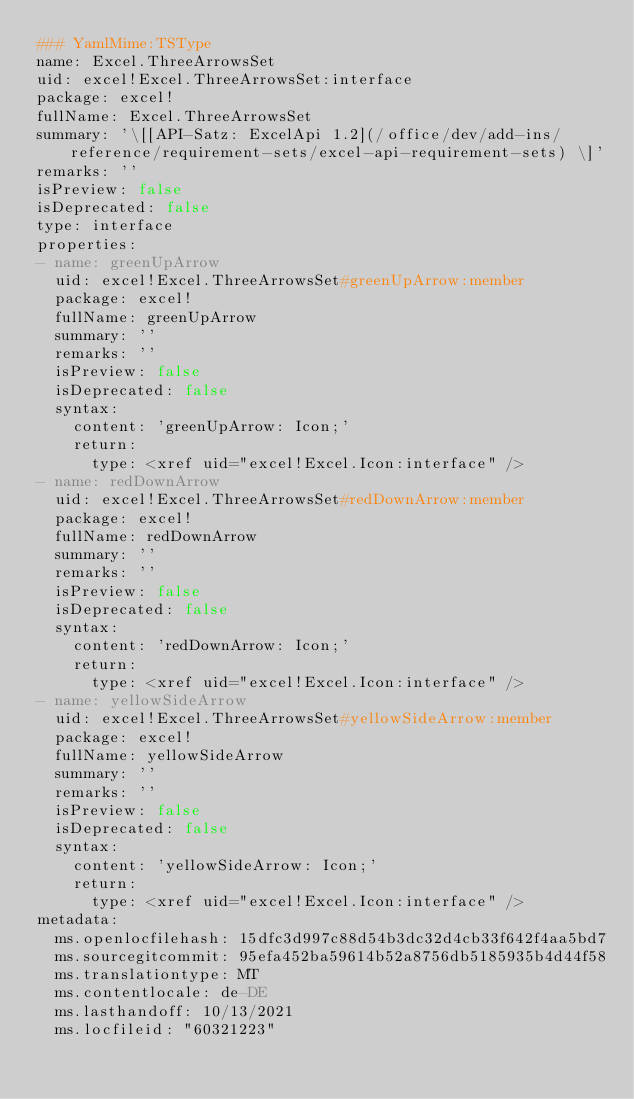<code> <loc_0><loc_0><loc_500><loc_500><_YAML_>### YamlMime:TSType
name: Excel.ThreeArrowsSet
uid: excel!Excel.ThreeArrowsSet:interface
package: excel!
fullName: Excel.ThreeArrowsSet
summary: '\[[API-Satz: ExcelApi 1.2](/office/dev/add-ins/reference/requirement-sets/excel-api-requirement-sets) \]'
remarks: ''
isPreview: false
isDeprecated: false
type: interface
properties:
- name: greenUpArrow
  uid: excel!Excel.ThreeArrowsSet#greenUpArrow:member
  package: excel!
  fullName: greenUpArrow
  summary: ''
  remarks: ''
  isPreview: false
  isDeprecated: false
  syntax:
    content: 'greenUpArrow: Icon;'
    return:
      type: <xref uid="excel!Excel.Icon:interface" />
- name: redDownArrow
  uid: excel!Excel.ThreeArrowsSet#redDownArrow:member
  package: excel!
  fullName: redDownArrow
  summary: ''
  remarks: ''
  isPreview: false
  isDeprecated: false
  syntax:
    content: 'redDownArrow: Icon;'
    return:
      type: <xref uid="excel!Excel.Icon:interface" />
- name: yellowSideArrow
  uid: excel!Excel.ThreeArrowsSet#yellowSideArrow:member
  package: excel!
  fullName: yellowSideArrow
  summary: ''
  remarks: ''
  isPreview: false
  isDeprecated: false
  syntax:
    content: 'yellowSideArrow: Icon;'
    return:
      type: <xref uid="excel!Excel.Icon:interface" />
metadata:
  ms.openlocfilehash: 15dfc3d997c88d54b3dc32d4cb33f642f4aa5bd7
  ms.sourcegitcommit: 95efa452ba59614b52a8756db5185935b4d44f58
  ms.translationtype: MT
  ms.contentlocale: de-DE
  ms.lasthandoff: 10/13/2021
  ms.locfileid: "60321223"
</code> 